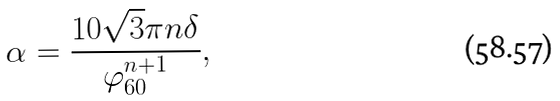<formula> <loc_0><loc_0><loc_500><loc_500>\alpha = \frac { 1 0 \sqrt { 3 } \pi n \delta } { \varphi _ { 6 0 } ^ { n + 1 } } ,</formula> 